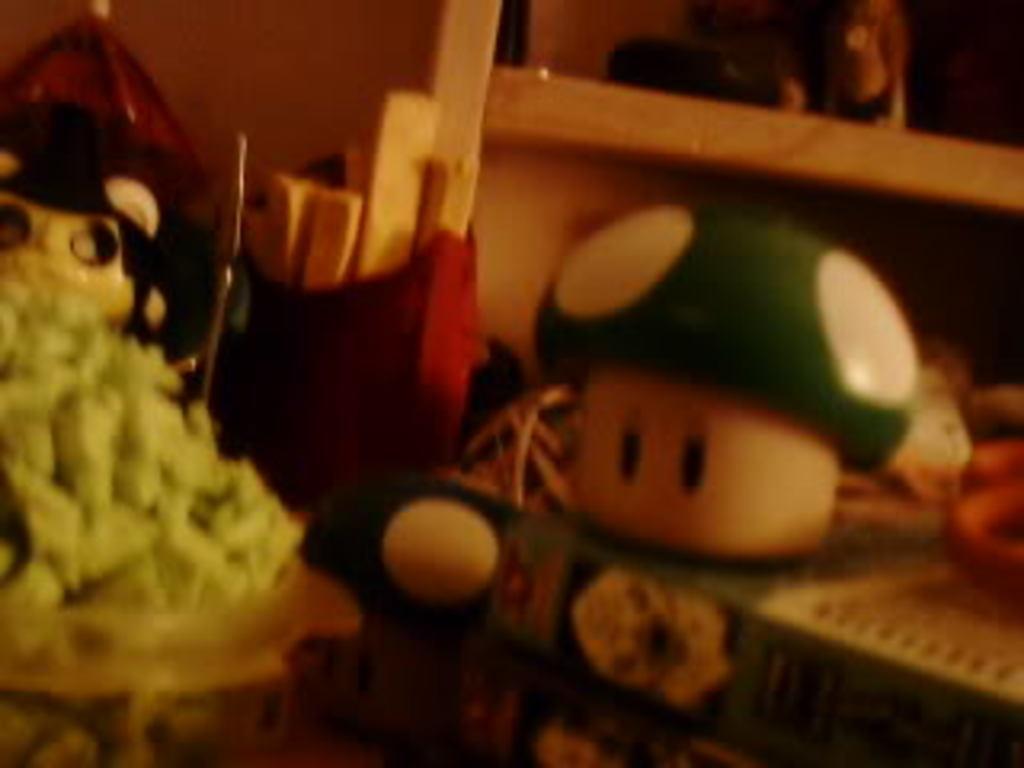Can you describe this image briefly? In this picture, we can see some objects like toys wooden objects, and we can see the wall. 